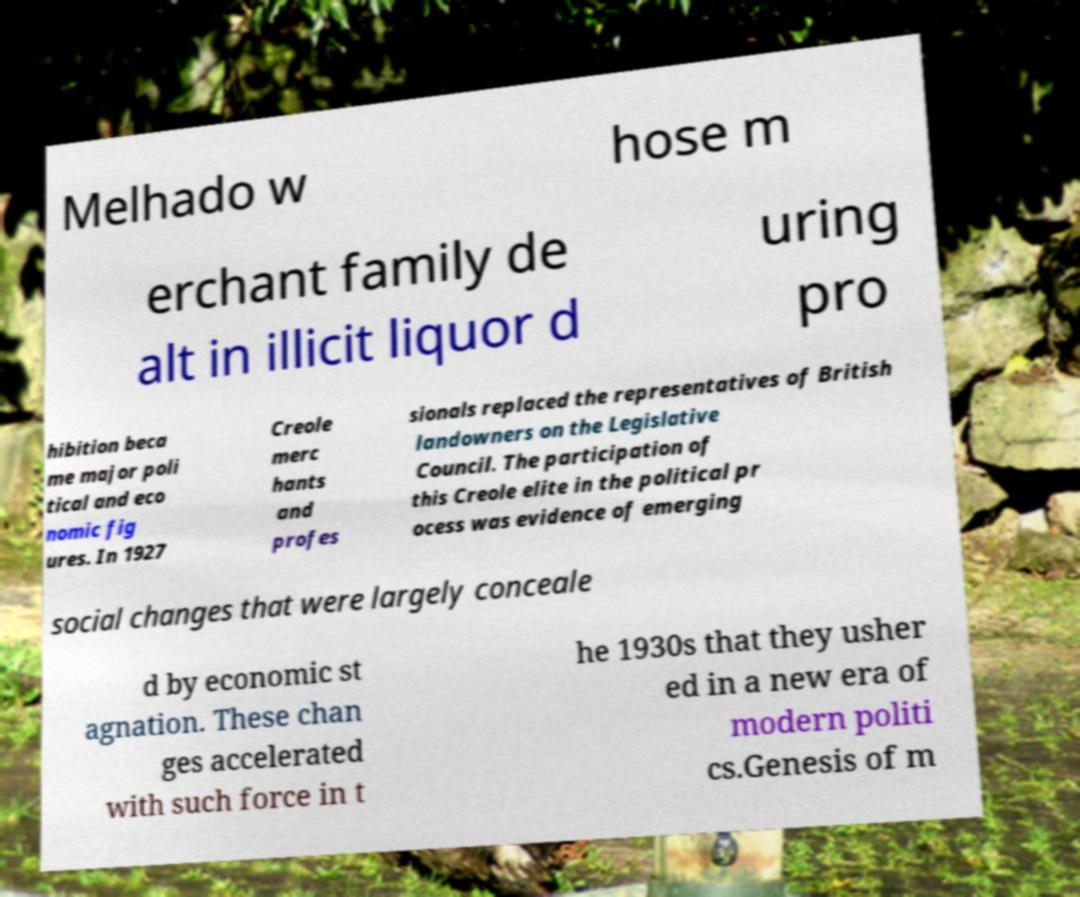Please read and relay the text visible in this image. What does it say? Melhado w hose m erchant family de alt in illicit liquor d uring pro hibition beca me major poli tical and eco nomic fig ures. In 1927 Creole merc hants and profes sionals replaced the representatives of British landowners on the Legislative Council. The participation of this Creole elite in the political pr ocess was evidence of emerging social changes that were largely conceale d by economic st agnation. These chan ges accelerated with such force in t he 1930s that they usher ed in a new era of modern politi cs.Genesis of m 